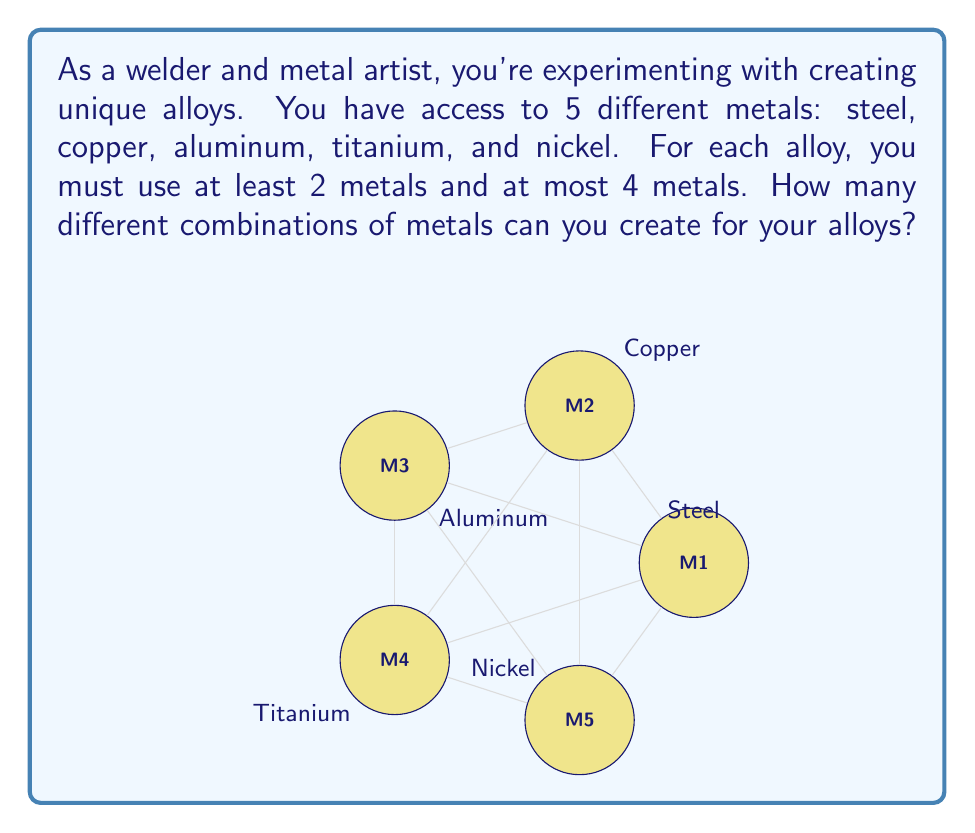Can you answer this question? Let's approach this step-by-step:

1) First, we need to calculate the number of combinations for each possible number of metals (2, 3, and 4):

   a) For 2 metals: We use the combination formula $\binom{5}{2}$
      $$\binom{5}{2} = \frac{5!}{2!(5-2)!} = \frac{5 \cdot 4}{2 \cdot 1} = 10$$

   b) For 3 metals: We use $\binom{5}{3}$
      $$\binom{5}{3} = \frac{5!}{3!(5-3)!} = \frac{5 \cdot 4 \cdot 3}{3 \cdot 2 \cdot 1} = 10$$

   c) For 4 metals: We use $\binom{5}{4}$
      $$\binom{5}{4} = \frac{5!}{4!(5-4)!} = \frac{5}{1} = 5$$

2) Now, we sum up all these combinations:
   $$10 + 10 + 5 = 25$$

Therefore, the total number of different combinations of metals for the alloys is 25.
Answer: 25 combinations 